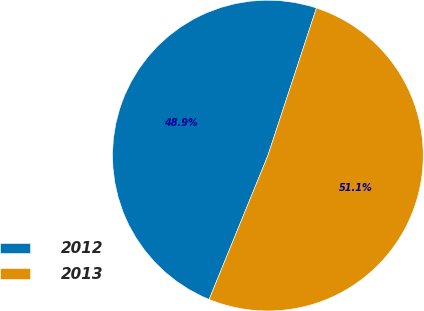Convert chart to OTSL. <chart><loc_0><loc_0><loc_500><loc_500><pie_chart><fcel>2012<fcel>2013<nl><fcel>48.89%<fcel>51.11%<nl></chart> 